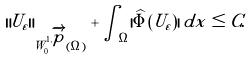Convert formula to latex. <formula><loc_0><loc_0><loc_500><loc_500>\| U _ { \varepsilon } \| _ { W _ { 0 } ^ { 1 , \overrightarrow { p } } ( \Omega ) } + \int _ { \Omega } | \widehat { \Phi } ( U _ { \varepsilon } ) | \, d x \leq C .</formula> 